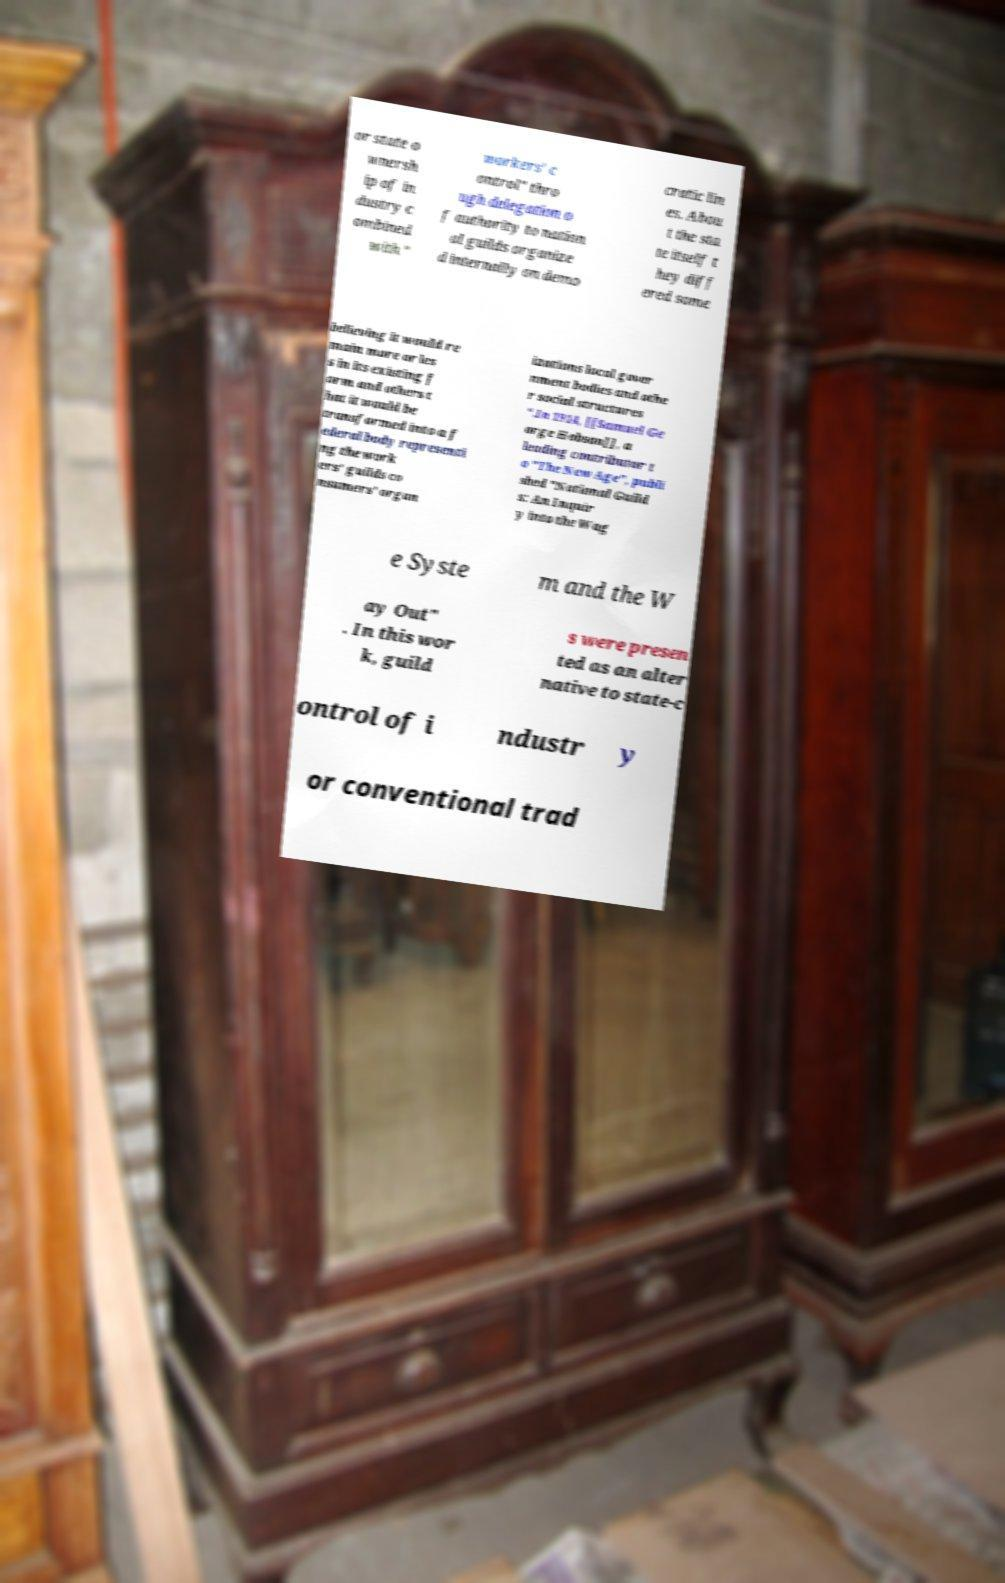What messages or text are displayed in this image? I need them in a readable, typed format. or state o wnersh ip of in dustry c ombined with " workers' c ontrol" thro ugh delegation o f authority to nation al guilds organize d internally on demo cratic lin es. Abou t the sta te itself t hey diff ered some believing it would re main more or les s in its existing f orm and others t hat it would be transformed into a f ederal body representi ng the work ers' guilds co nsumers' organ izations local gover nment bodies and othe r social structures ".In 1914, [[Samuel Ge orge Hobson]], a leading contributor t o "The New Age", publi shed "National Guild s: An Inquir y into the Wag e Syste m and the W ay Out" . In this wor k, guild s were presen ted as an alter native to state-c ontrol of i ndustr y or conventional trad 